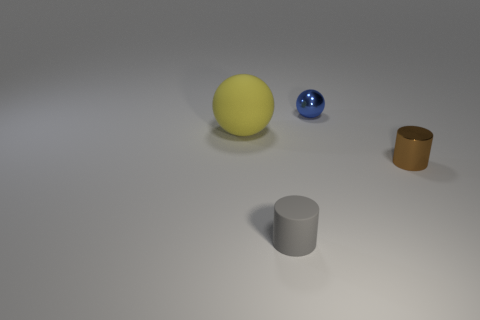Add 4 yellow matte spheres. How many objects exist? 8 Subtract all tiny red matte blocks. Subtract all tiny matte things. How many objects are left? 3 Add 2 rubber cylinders. How many rubber cylinders are left? 3 Add 1 big objects. How many big objects exist? 2 Subtract 0 green balls. How many objects are left? 4 